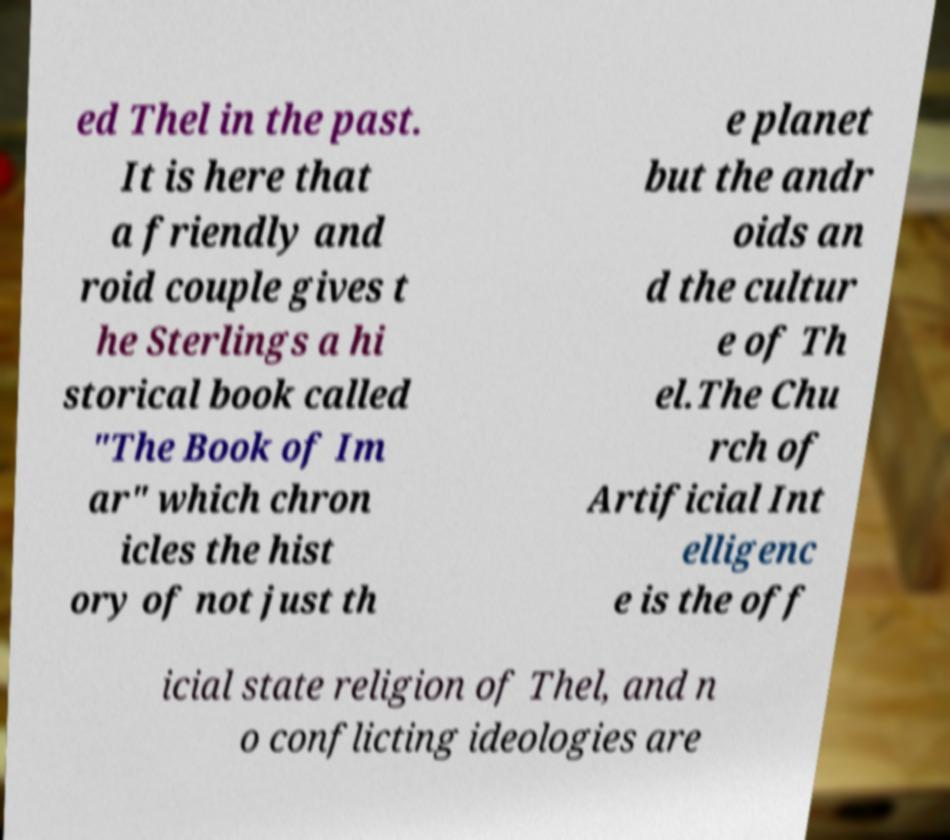Please identify and transcribe the text found in this image. ed Thel in the past. It is here that a friendly and roid couple gives t he Sterlings a hi storical book called "The Book of Im ar" which chron icles the hist ory of not just th e planet but the andr oids an d the cultur e of Th el.The Chu rch of Artificial Int elligenc e is the off icial state religion of Thel, and n o conflicting ideologies are 